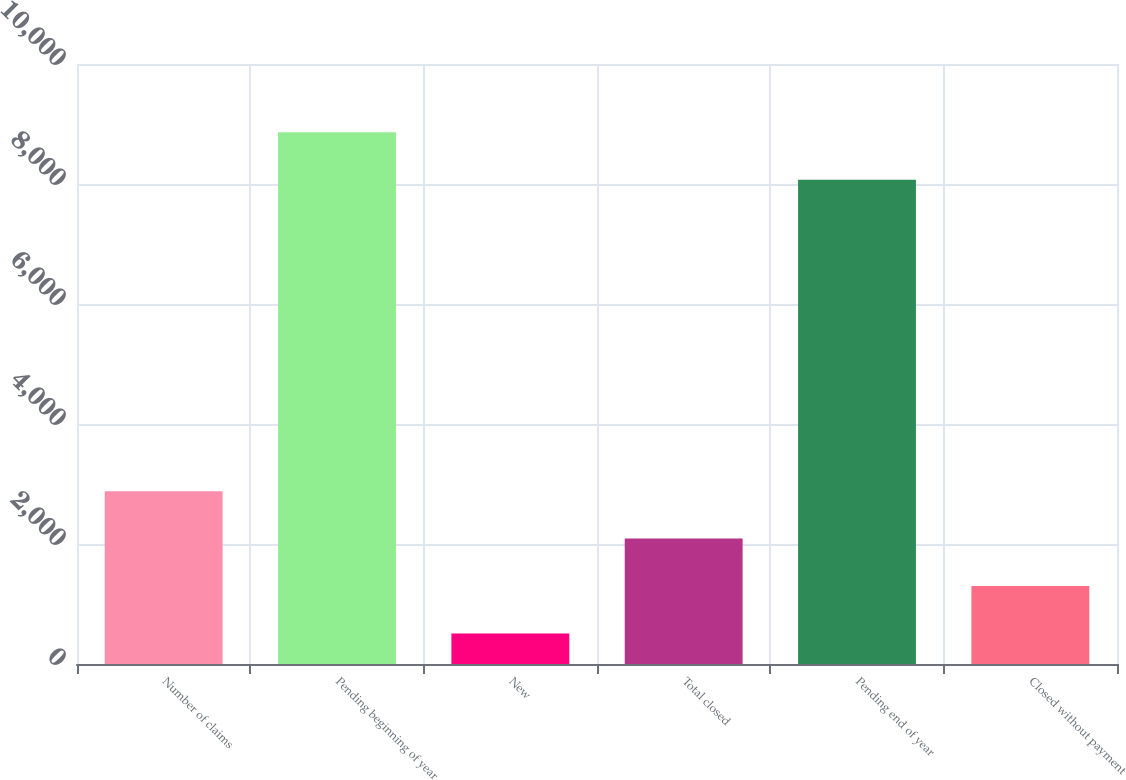Convert chart to OTSL. <chart><loc_0><loc_0><loc_500><loc_500><bar_chart><fcel>Number of claims<fcel>Pending beginning of year<fcel>New<fcel>Total closed<fcel>Pending end of year<fcel>Closed without payment<nl><fcel>2881.2<fcel>8863.4<fcel>507<fcel>2089.8<fcel>8072<fcel>1298.4<nl></chart> 